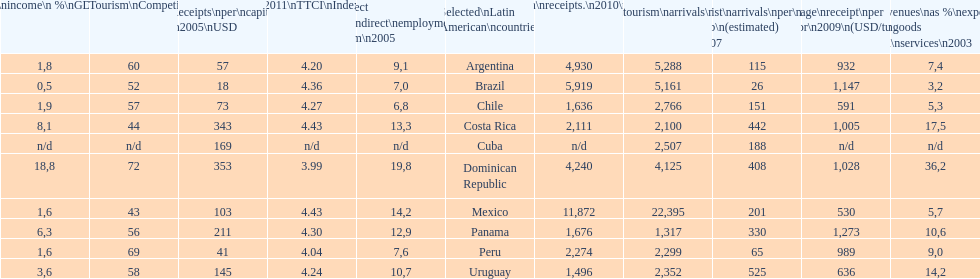What country had the least arrivals per 1000 inhabitants in 2007(estimated)? Brazil. 